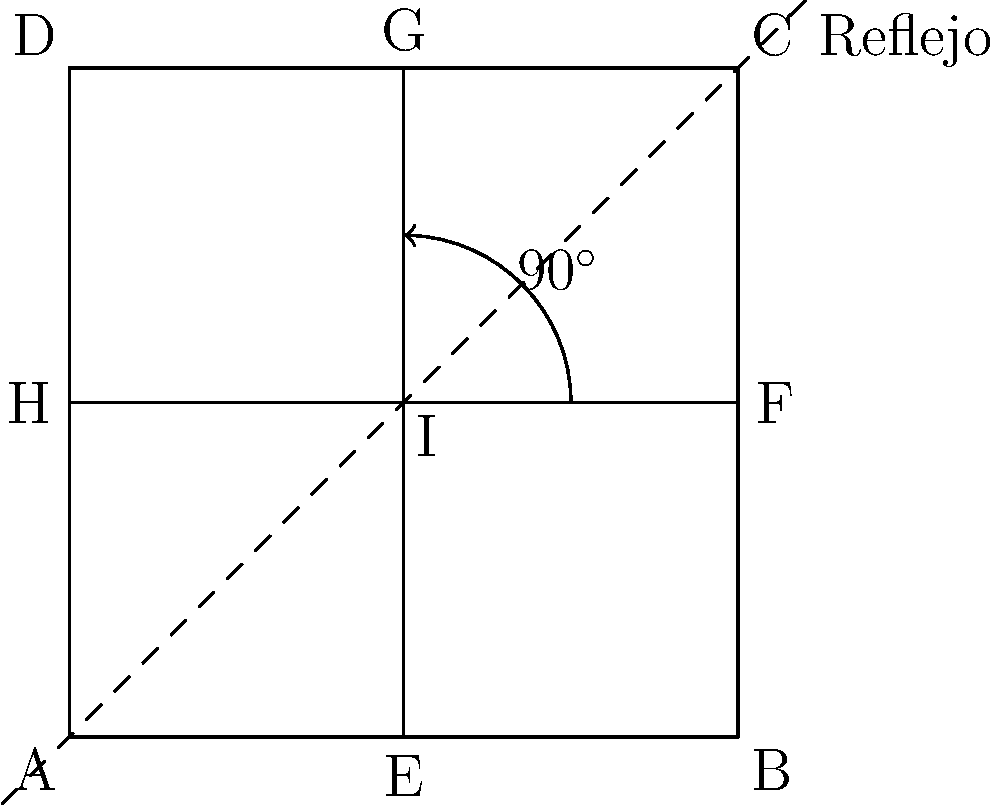Considere una cuadrícula de diseño web 3x3 como se muestra en la imagen. Si aplicamos una rotación de 90° en sentido horario seguida de una reflexión sobre la diagonal principal (de la esquina superior izquierda a la inferior derecha), ¿cuál será la posición final del punto E? Exprese su respuesta como coordenadas (x,y) en el sistema de la cuadrícula. Para resolver este problema, seguiremos estos pasos:

1. Identificar la posición inicial de E:
   E está inicialmente en (1,0)

2. Aplicar la rotación de 90° en sentido horario:
   - La rotación de 90° en sentido horario transforma (x,y) en (y,-x)
   - E(1,0) se convierte en (0,-1)

3. Aplicar la reflexión sobre la diagonal principal:
   - La reflexión sobre la diagonal principal intercambia las coordenadas x e y
   - (0,-1) se convierte en (-1,0)

4. Ajustar las coordenadas al sistema de la cuadrícula:
   - En el sistema de la cuadrícula, las coordenadas van de 0 a 2 en ambos ejes
   - (-1,0) en el sistema transformado equivale a (0,2) en el sistema de la cuadrícula

Por lo tanto, la posición final de E después de aplicar ambas transformaciones es (0,2), que corresponde al punto D en la cuadrícula original.
Answer: (0,2) 